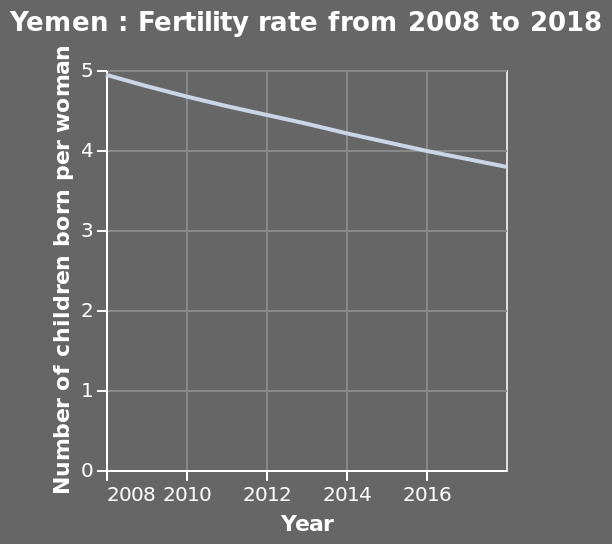<image>
Offer a thorough analysis of the image. The number of children born per women has slightly decrease between 2008 and 2018 showing that children born per women in 2008 were 5 and in 2018 were 4. What is the title of the line plot? The title of the line plot is "Yemen: Fertility rate from 2008 to 2018." 